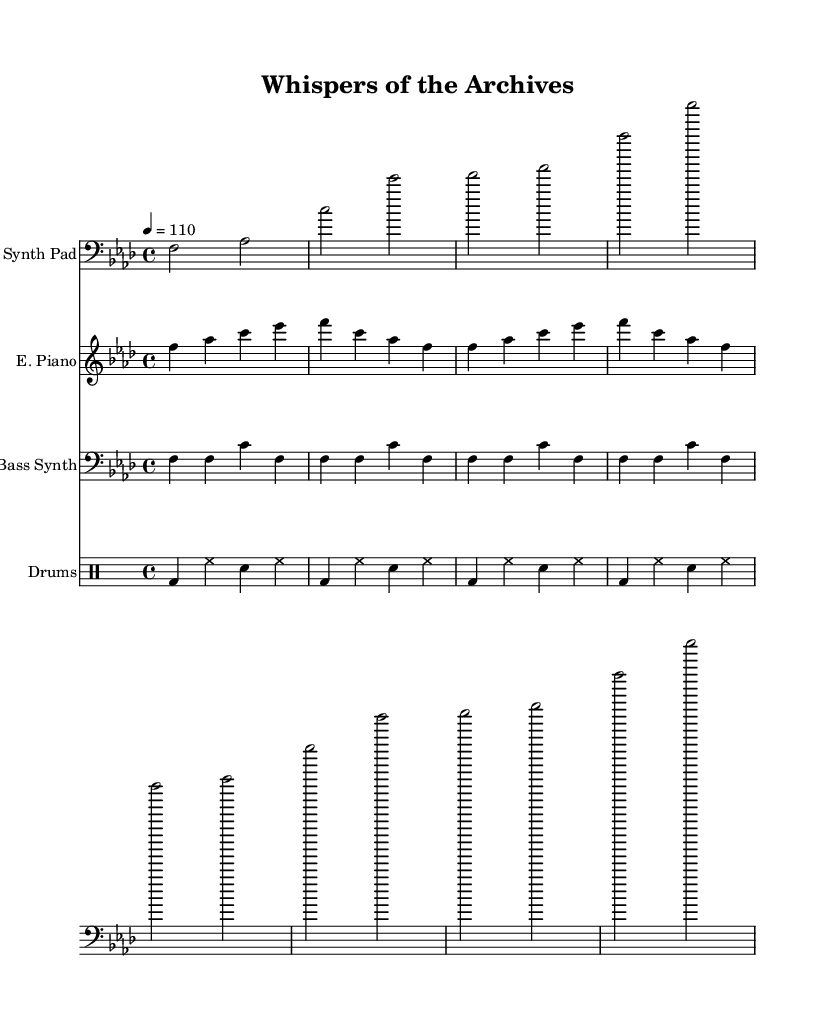What is the key signature of this music? The key signature is F minor, which includes four flats (B♭, E♭, A♭, and D♭). This can be identified at the beginning of the score where the key signature is displayed.
Answer: F minor What is the time signature of this music? The time signature is 4/4, which indicates there are four beats in each measure and the quarter note gets one beat. This can be found just after the clef sign at the beginning of the score.
Answer: 4/4 What is the tempo marking of this music? The tempo marking is 110 beats per minute, which is indicated at the beginning of the score with the note "4 = 110". This tells the performer how fast to play the piece.
Answer: 110 How many measures are in the synth pad section? There are four measures in the synth pad section, as indicated by the repeated group of notes across the staff. Counting the measures visually shows that there are four distinct groupings.
Answer: 4 What type of sound is indicated by the term "E. Piano"? The "E. Piano" indicates the instrument is an electric piano, which is a common instrument in ambient house music for its soft, warm sound that complements atmospheric pieces. This is indicated in the staff label.
Answer: Electric piano What rhythmic pattern is used in the drum machine section? The rhythmic pattern consists of bass drum, hi-hat, snare, followed by hi-hat, creating a repetitive beat typical in house music. This can be inferred from the notated rhythm pattern in the drum staff.
Answer: Bass-HiHat-Snare-HiHat 